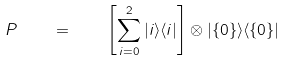Convert formula to latex. <formula><loc_0><loc_0><loc_500><loc_500>P \quad = \quad \left [ \sum _ { i = 0 } ^ { 2 } | i \rangle \langle i | \right ] \otimes | \{ 0 \} \rangle \langle \{ 0 \} |</formula> 